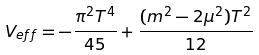<formula> <loc_0><loc_0><loc_500><loc_500>V _ { e f f } = - \frac { \pi ^ { 2 } T ^ { 4 } } { 4 5 } + \frac { ( m ^ { 2 } - 2 \mu ^ { 2 } ) T ^ { 2 } } { 1 2 }</formula> 